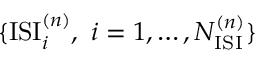Convert formula to latex. <formula><loc_0><loc_0><loc_500><loc_500>\{ I S I _ { i } ^ { ( n ) } , i = 1 , \dots , N _ { I S I } ^ { ( n ) } \}</formula> 